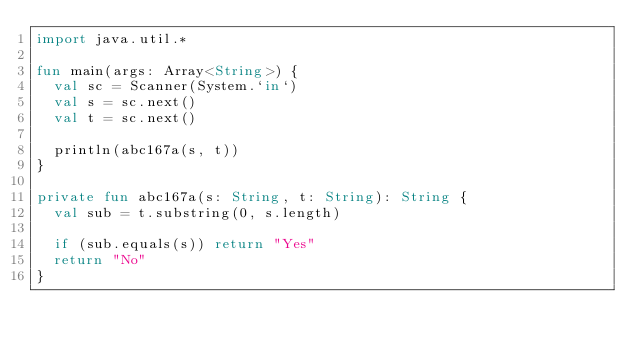<code> <loc_0><loc_0><loc_500><loc_500><_Kotlin_>import java.util.*

fun main(args: Array<String>) {
  val sc = Scanner(System.`in`)
  val s = sc.next()
  val t = sc.next()

  println(abc167a(s, t))
}

private fun abc167a(s: String, t: String): String {
  val sub = t.substring(0, s.length)

  if (sub.equals(s)) return "Yes"
  return "No"
}
</code> 